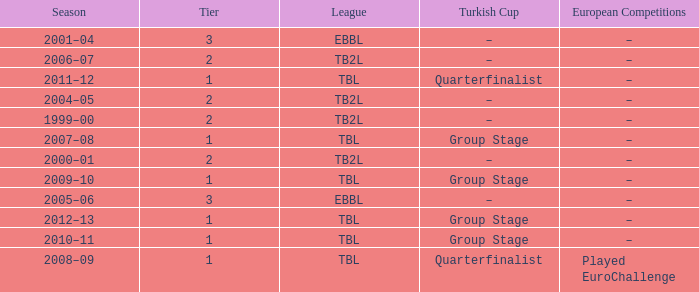Tier of 2, and a Season of 2004–05 is what European competitions? –. 